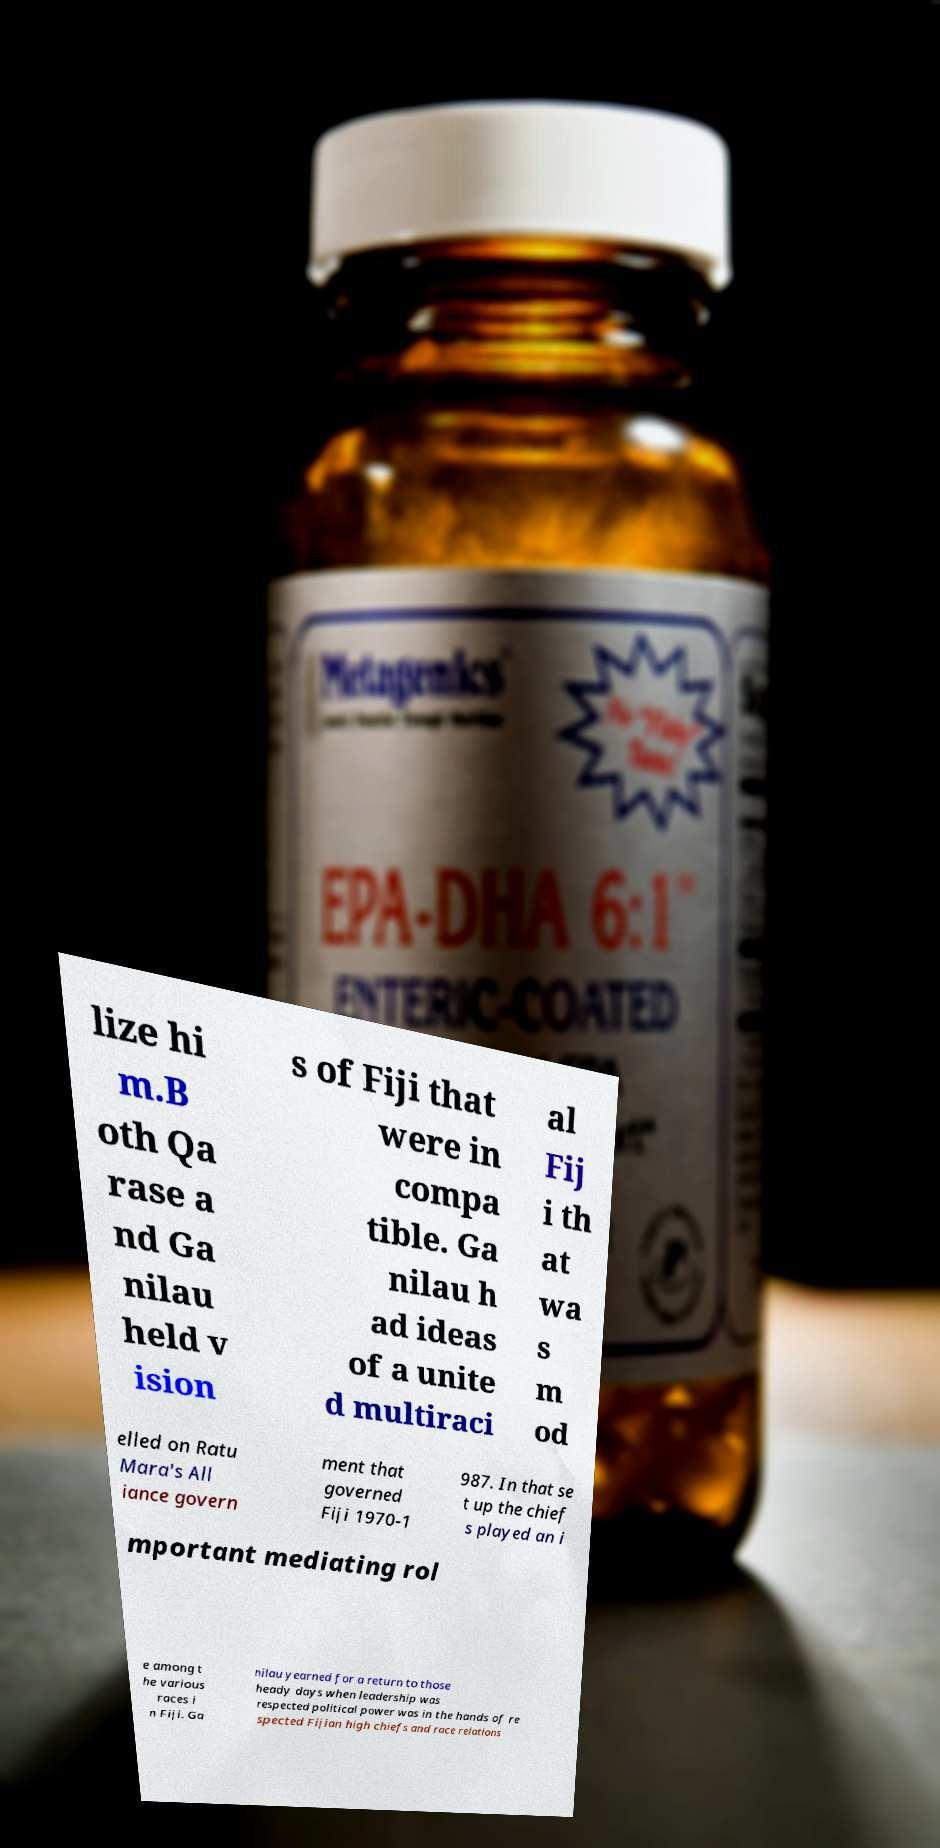Could you assist in decoding the text presented in this image and type it out clearly? lize hi m.B oth Qa rase a nd Ga nilau held v ision s of Fiji that were in compa tible. Ga nilau h ad ideas of a unite d multiraci al Fij i th at wa s m od elled on Ratu Mara's All iance govern ment that governed Fiji 1970-1 987. In that se t up the chief s played an i mportant mediating rol e among t he various races i n Fiji. Ga nilau yearned for a return to those heady days when leadership was respected political power was in the hands of re spected Fijian high chiefs and race relations 